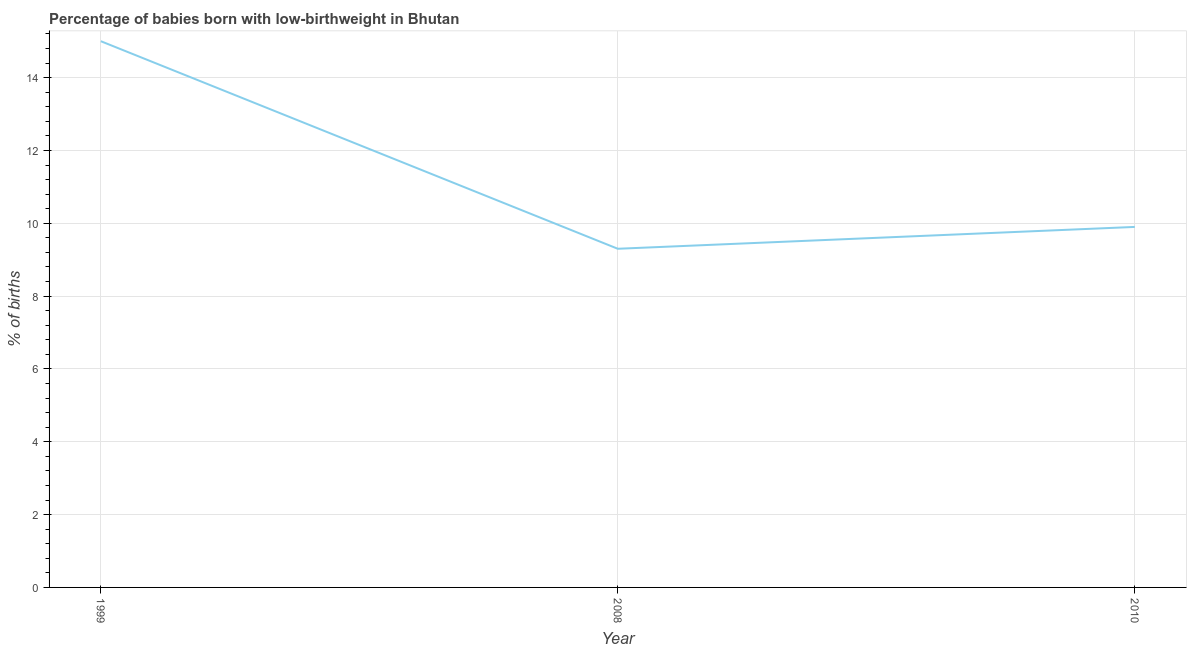Across all years, what is the minimum percentage of babies who were born with low-birthweight?
Your answer should be compact. 9.3. In which year was the percentage of babies who were born with low-birthweight minimum?
Offer a terse response. 2008. What is the sum of the percentage of babies who were born with low-birthweight?
Offer a very short reply. 34.2. What is the difference between the percentage of babies who were born with low-birthweight in 2008 and 2010?
Make the answer very short. -0.6. What is the average percentage of babies who were born with low-birthweight per year?
Provide a succinct answer. 11.4. In how many years, is the percentage of babies who were born with low-birthweight greater than 0.4 %?
Offer a very short reply. 3. Do a majority of the years between 1999 and 2008 (inclusive) have percentage of babies who were born with low-birthweight greater than 6 %?
Make the answer very short. Yes. What is the ratio of the percentage of babies who were born with low-birthweight in 2008 to that in 2010?
Your answer should be compact. 0.94. Is the difference between the percentage of babies who were born with low-birthweight in 2008 and 2010 greater than the difference between any two years?
Give a very brief answer. No. Is the sum of the percentage of babies who were born with low-birthweight in 1999 and 2008 greater than the maximum percentage of babies who were born with low-birthweight across all years?
Provide a succinct answer. Yes. What is the difference between the highest and the lowest percentage of babies who were born with low-birthweight?
Keep it short and to the point. 5.7. How many lines are there?
Offer a very short reply. 1. How many years are there in the graph?
Ensure brevity in your answer.  3. Are the values on the major ticks of Y-axis written in scientific E-notation?
Your response must be concise. No. What is the title of the graph?
Give a very brief answer. Percentage of babies born with low-birthweight in Bhutan. What is the label or title of the X-axis?
Give a very brief answer. Year. What is the label or title of the Y-axis?
Give a very brief answer. % of births. What is the % of births in 2010?
Make the answer very short. 9.9. What is the difference between the % of births in 1999 and 2010?
Your answer should be compact. 5.1. What is the difference between the % of births in 2008 and 2010?
Make the answer very short. -0.6. What is the ratio of the % of births in 1999 to that in 2008?
Provide a succinct answer. 1.61. What is the ratio of the % of births in 1999 to that in 2010?
Make the answer very short. 1.51. What is the ratio of the % of births in 2008 to that in 2010?
Your answer should be compact. 0.94. 